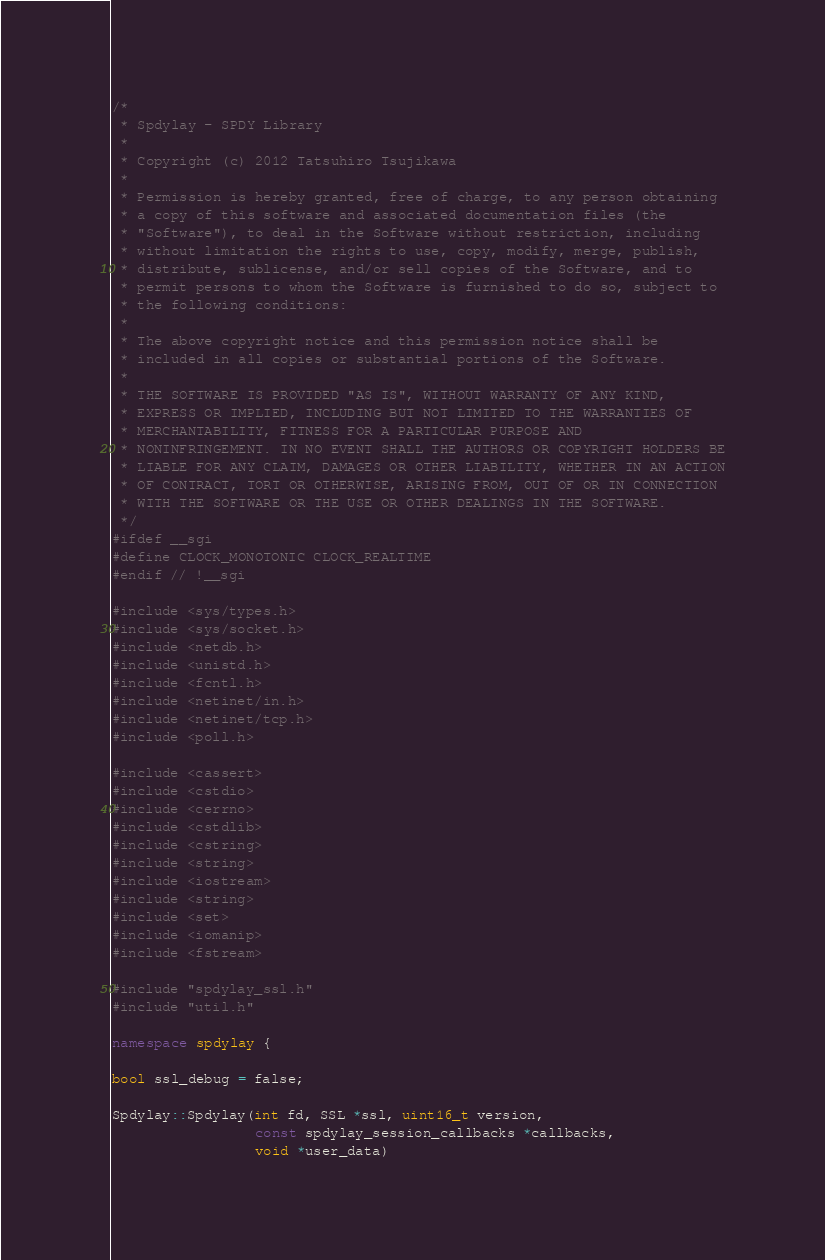Convert code to text. <code><loc_0><loc_0><loc_500><loc_500><_C++_>/*
 * Spdylay - SPDY Library
 *
 * Copyright (c) 2012 Tatsuhiro Tsujikawa
 *
 * Permission is hereby granted, free of charge, to any person obtaining
 * a copy of this software and associated documentation files (the
 * "Software"), to deal in the Software without restriction, including
 * without limitation the rights to use, copy, modify, merge, publish,
 * distribute, sublicense, and/or sell copies of the Software, and to
 * permit persons to whom the Software is furnished to do so, subject to
 * the following conditions:
 *
 * The above copyright notice and this permission notice shall be
 * included in all copies or substantial portions of the Software.
 *
 * THE SOFTWARE IS PROVIDED "AS IS", WITHOUT WARRANTY OF ANY KIND,
 * EXPRESS OR IMPLIED, INCLUDING BUT NOT LIMITED TO THE WARRANTIES OF
 * MERCHANTABILITY, FITNESS FOR A PARTICULAR PURPOSE AND
 * NONINFRINGEMENT. IN NO EVENT SHALL THE AUTHORS OR COPYRIGHT HOLDERS BE
 * LIABLE FOR ANY CLAIM, DAMAGES OR OTHER LIABILITY, WHETHER IN AN ACTION
 * OF CONTRACT, TORT OR OTHERWISE, ARISING FROM, OUT OF OR IN CONNECTION
 * WITH THE SOFTWARE OR THE USE OR OTHER DEALINGS IN THE SOFTWARE.
 */
#ifdef __sgi
#define CLOCK_MONOTONIC CLOCK_REALTIME
#endif // !__sgi

#include <sys/types.h>
#include <sys/socket.h>
#include <netdb.h>
#include <unistd.h>
#include <fcntl.h>
#include <netinet/in.h>
#include <netinet/tcp.h>
#include <poll.h>

#include <cassert>
#include <cstdio>
#include <cerrno>
#include <cstdlib>
#include <cstring>
#include <string>
#include <iostream>
#include <string>
#include <set>
#include <iomanip>
#include <fstream>

#include "spdylay_ssl.h"
#include "util.h"

namespace spdylay {

bool ssl_debug = false;

Spdylay::Spdylay(int fd, SSL *ssl, uint16_t version,
                 const spdylay_session_callbacks *callbacks,
                 void *user_data)</code> 